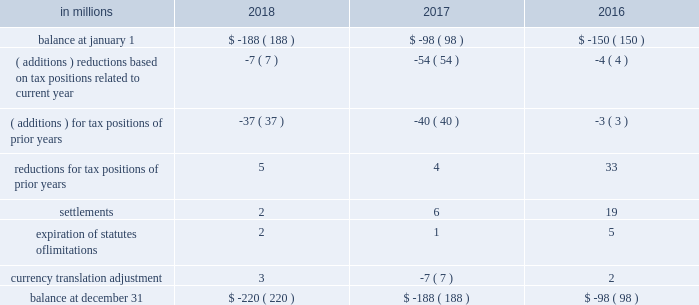( a ) the net change in the total valuation allowance for the years ended december 31 , 2018 and 2017 was an increase of $ 12 million and an increase of $ 26 million , respectively .
Deferred income tax assets and liabilities are recorded in the accompanying consolidated balance sheet under the captions deferred charges and other assets and deferred income taxes .
There was a decrease in deferred income tax assets principally relating to the utilization of u.s .
Federal alternative minimum tax credits as permitted under tax reform .
Deferred tax liabilities increased primarily due to the tax deferral of the book gain recognized on the transfer of the north american consumer packaging business to a subsidiary of graphic packaging holding company .
Of the $ 1.5 billion of deferred tax liabilities for forestlands , related installment sales , and investment in subsidiary , $ 884 million is attributable to an investment in subsidiary and relates to a 2006 international paper installment sale of forestlands and $ 538 million is attributable to a 2007 temple-inland installment sale of forestlands ( see note 14 ) .
A reconciliation of the beginning and ending amount of unrecognized tax benefits for the years ended december 31 , 2018 , 2017 and 2016 is as follows: .
If the company were to prevail on the unrecognized tax benefits recorded , substantially all of the balances at december 31 , 2018 , 2017 and 2016 would benefit the effective tax rate .
The company accrues interest on unrecognized tax benefits as a component of interest expense .
Penalties , if incurred , are recognized as a component of income tax expense .
The company had approximately $ 21 million and $ 17 million accrued for the payment of estimated interest and penalties associated with unrecognized tax benefits at december 31 , 2018 and 2017 , respectively .
The major jurisdictions where the company files income tax returns are the united states , brazil , france , poland and russia .
Generally , tax years 2006 through 2017 remain open and subject to examination by the relevant tax authorities .
The company frequently faces challenges regarding the amount of taxes due .
These challenges include positions taken by the company related to the timing , nature , and amount of deductions and the allocation of income among various tax jurisdictions .
Pending audit settlements and the expiration of statute of limitations could reduce the uncertain tax positions by $ 30 million during the next twelve months .
The brazilian federal revenue service has challenged the deductibility of goodwill amortization generated in a 2007 acquisition by international paper do brasil ltda. , a wholly-owned subsidiary of the company .
The company received assessments for the tax years 2007-2015 totaling approximately $ 150 million in tax , and $ 380 million in interest and penalties as of december 31 , 2018 ( adjusted for variation in currency exchange rates ) .
After a previous favorable ruling challenging the basis for these assessments , we received an unfavorable decision in october 2018 from the brazilian administrative council of tax appeals .
The company intends to further appeal the matter in the brazilian federal courts in 2019 ; however , this tax litigation matter may take many years to resolve .
The company believes that it has appropriately evaluated the transaction underlying these assessments , and has concluded based on brazilian tax law , that its tax position would be sustained .
The company intends to vigorously defend its position against the current assessments and any similar assessments that may be issued for tax years subsequent to 2015 .
International paper uses the flow-through method to account for investment tax credits earned on eligible open-loop biomass facilities and combined heat and power system expenditures .
Under this method , the investment tax credits are recognized as a reduction to income tax expense in the year they are earned rather than a reduction in the asset basis .
The company recorded a tax benefit of $ 6 million during 2018 and recorded a tax benefit of $ 68 million during 2017 related to investment tax credits earned in tax years 2013-2017. .
Considering the years 2016-2018 , what is the average value for settlements , in millions? 
Rationale: it is the sum of all values divided by three .
Computations: table_average(settlements, none)
Answer: 9.0. 